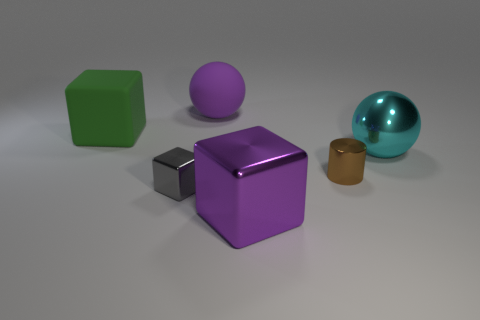Can you describe the arrangement of objects in terms of their spatial relationships? The objects are spaced relatively evenly across a flat surface, with no overlapping. This arrangement allows each object to be distinctly visible, highlighting their individual shapes and colors. The spherical objects are placed towards the right, drawing attention by their curvature contrasting with the angular shapes of the cubes on the left. Does this arrangement suggest any particular theme or purpose? The arrangement seems methodical and could suggest a theme of comparison and contrast, emphasizing differences in shapes, textures, and colors. It might be used to study or demonstrate properties of geometric shapes and material textures in a controlled setting. 